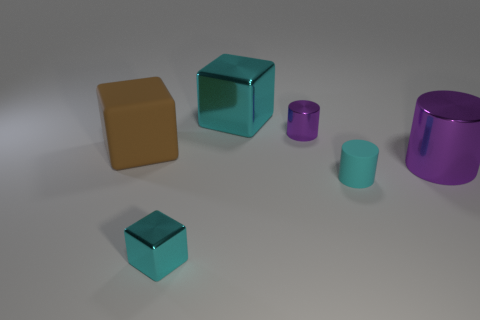Subtract all tiny metal cubes. How many cubes are left? 2 Add 1 green cylinders. How many objects exist? 7 Subtract all yellow blocks. Subtract all green cylinders. How many blocks are left? 3 Subtract all purple cubes. How many purple cylinders are left? 2 Subtract all large cyan metal objects. Subtract all metal cylinders. How many objects are left? 3 Add 3 brown cubes. How many brown cubes are left? 4 Add 4 big rubber blocks. How many big rubber blocks exist? 5 Subtract all cyan cylinders. How many cylinders are left? 2 Subtract 0 green blocks. How many objects are left? 6 Subtract 2 cylinders. How many cylinders are left? 1 